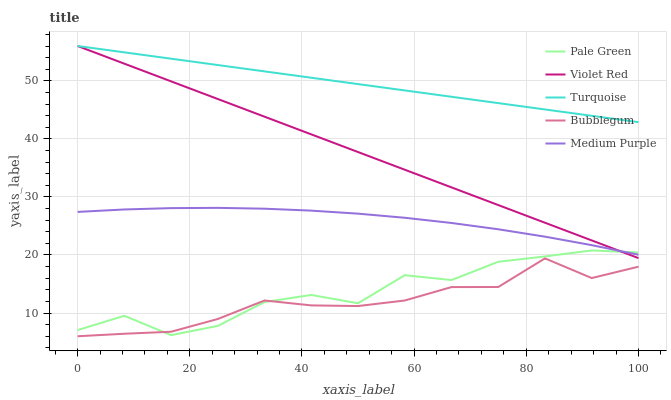Does Bubblegum have the minimum area under the curve?
Answer yes or no. Yes. Does Turquoise have the maximum area under the curve?
Answer yes or no. Yes. Does Violet Red have the minimum area under the curve?
Answer yes or no. No. Does Violet Red have the maximum area under the curve?
Answer yes or no. No. Is Turquoise the smoothest?
Answer yes or no. Yes. Is Pale Green the roughest?
Answer yes or no. Yes. Is Violet Red the smoothest?
Answer yes or no. No. Is Violet Red the roughest?
Answer yes or no. No. Does Violet Red have the lowest value?
Answer yes or no. No. Does Turquoise have the highest value?
Answer yes or no. Yes. Does Pale Green have the highest value?
Answer yes or no. No. Is Medium Purple less than Turquoise?
Answer yes or no. Yes. Is Turquoise greater than Medium Purple?
Answer yes or no. Yes. Does Medium Purple intersect Turquoise?
Answer yes or no. No. 